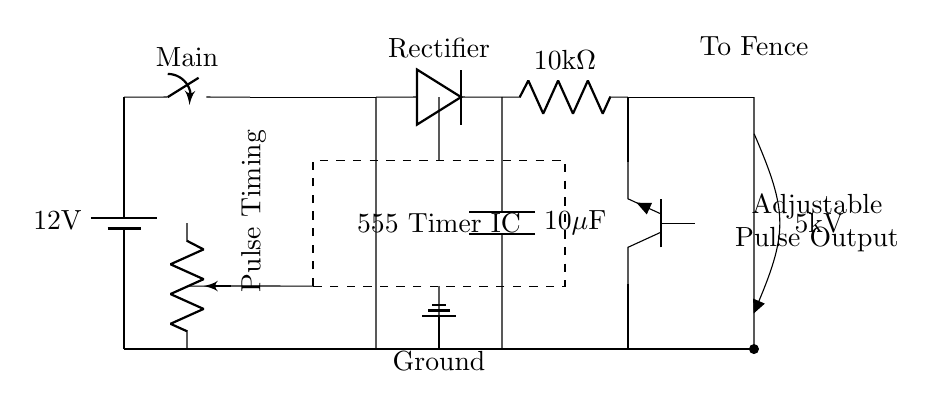What is the main voltage source in the circuit? The main voltage source is a 12V battery, which is the first component depicted in the circuit diagram.
Answer: 12V What component is used to regulate pulse timing? The pulse timing is adjusted using a potentiometer, which is indicated in the circuit symbol with "Pulse Timing" alongside it.
Answer: Potentiometer What is the output voltage to the fence? The output voltage to the fence is represented as 5kV, which is indicated by the labeled output terminal.
Answer: 5kV How many microfarads is the capacitor in this circuit? The capacitor is labeled with a capacitance of 10 microfarads, which is clearly indicated in the diagram next to the capacitor symbol.
Answer: 10 microfarads What type of timer IC is used in this circuit? The timer used is a 555 Timer IC, which is enclosed in a dashed rectangle in the diagram, indicating its function in pulse generation.
Answer: 555 Timer IC What is the purpose of the transformer in this circuit? The transformers are used to step up the voltage to high levels necessary for the electric fence, thus, they are key components in achieving the desired 5kV output.
Answer: Step-up voltage How does the switch in the circuit function? The main switch allows control over the circuit by connecting or disconnecting the power to the transformer, thus influencing the operation of the entire circuit.
Answer: Control power 